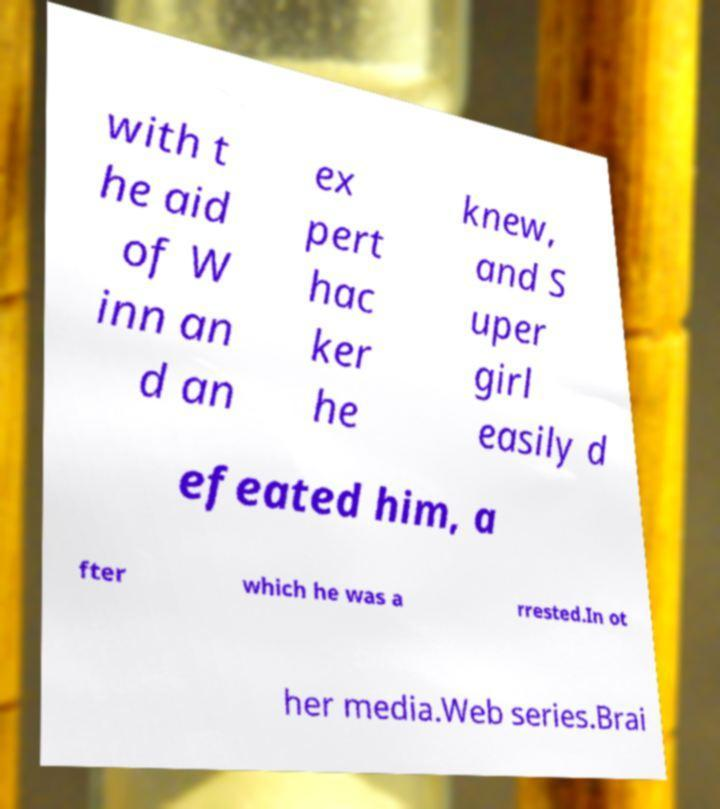There's text embedded in this image that I need extracted. Can you transcribe it verbatim? with t he aid of W inn an d an ex pert hac ker he knew, and S uper girl easily d efeated him, a fter which he was a rrested.In ot her media.Web series.Brai 